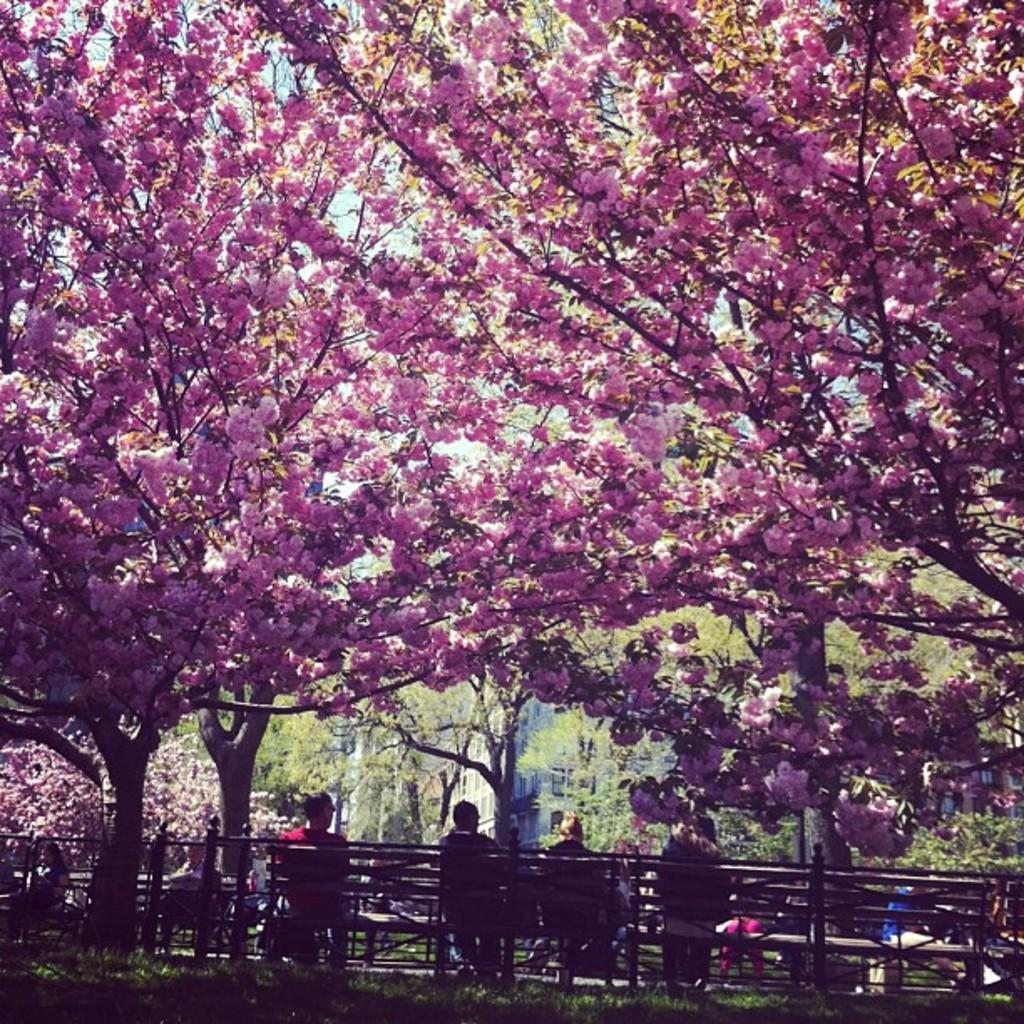What can be seen at the top of the image? There is blossom at the top of the image. What are the people in the image doing? The persons are sitting on benches at the bottom of the image. What type of system is being used by the pet in the image? There is no pet present in the image, so it is not possible to answer a question about a pet or a system. What riddle can be solved by observing the blossom in the image? There is no riddle associated with the blossom in the image; it is simply a visual element. 